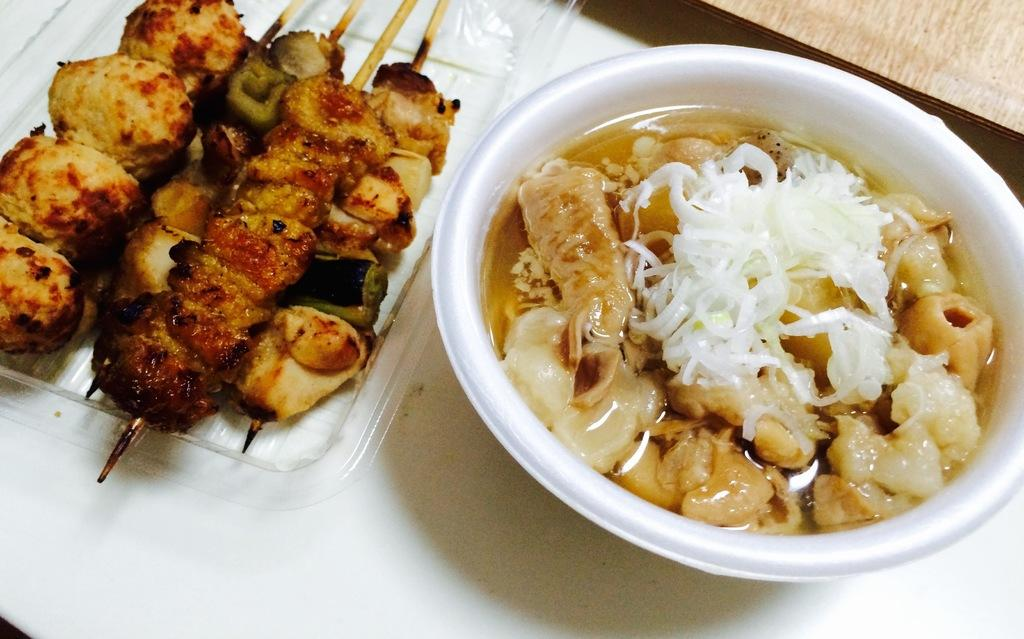What type of food is on the tray in the image? There is a tray of brochette in the image. What is in the bowl that is visible in the image? The bowl contains soup, meat, and other ingredients. Where are the tray and bowl located in the image? The tray and bowl are placed on a table. What type of smoke can be seen coming from the bowl in the image? There is no smoke present in the image; it features a bowl of soup, meat, and other ingredients. 